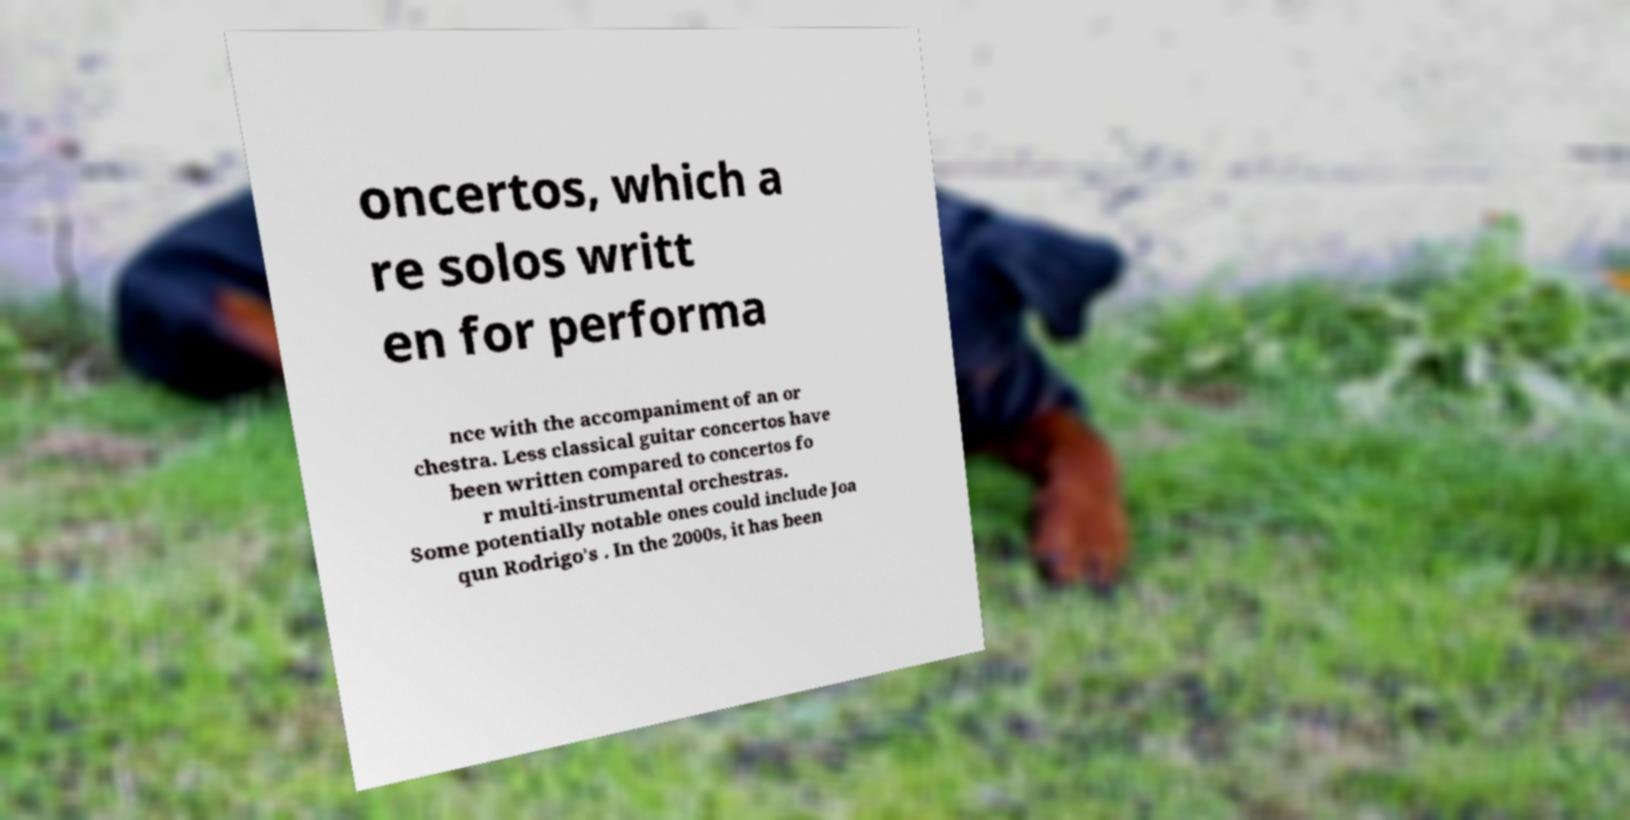What messages or text are displayed in this image? I need them in a readable, typed format. oncertos, which a re solos writt en for performa nce with the accompaniment of an or chestra. Less classical guitar concertos have been written compared to concertos fo r multi-instrumental orchestras. Some potentially notable ones could include Joa qun Rodrigo's . In the 2000s, it has been 